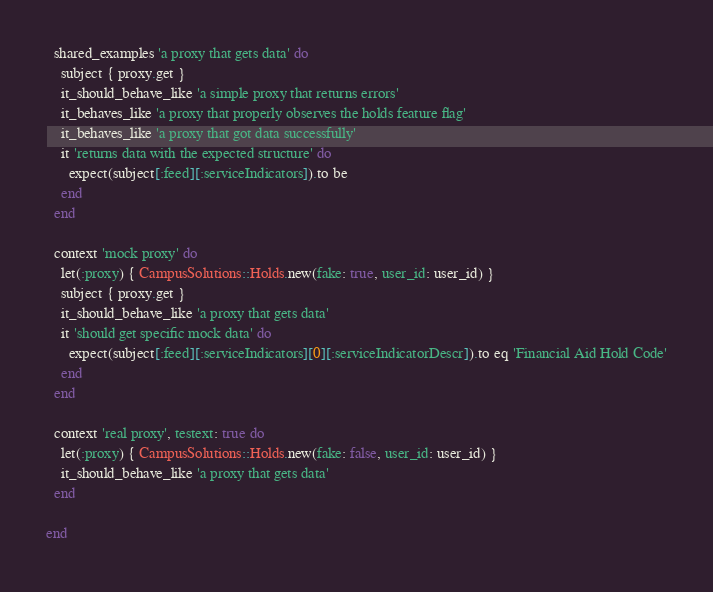Convert code to text. <code><loc_0><loc_0><loc_500><loc_500><_Ruby_>
  shared_examples 'a proxy that gets data' do
    subject { proxy.get }
    it_should_behave_like 'a simple proxy that returns errors'
    it_behaves_like 'a proxy that properly observes the holds feature flag'
    it_behaves_like 'a proxy that got data successfully'
    it 'returns data with the expected structure' do
      expect(subject[:feed][:serviceIndicators]).to be
    end
  end

  context 'mock proxy' do
    let(:proxy) { CampusSolutions::Holds.new(fake: true, user_id: user_id) }
    subject { proxy.get }
    it_should_behave_like 'a proxy that gets data'
    it 'should get specific mock data' do
      expect(subject[:feed][:serviceIndicators][0][:serviceIndicatorDescr]).to eq 'Financial Aid Hold Code'
    end
  end

  context 'real proxy', testext: true do
    let(:proxy) { CampusSolutions::Holds.new(fake: false, user_id: user_id) }
    it_should_behave_like 'a proxy that gets data'
  end

end
</code> 